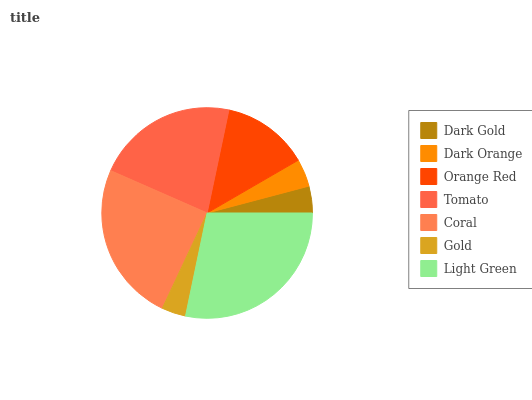Is Gold the minimum?
Answer yes or no. Yes. Is Light Green the maximum?
Answer yes or no. Yes. Is Dark Orange the minimum?
Answer yes or no. No. Is Dark Orange the maximum?
Answer yes or no. No. Is Dark Orange greater than Dark Gold?
Answer yes or no. Yes. Is Dark Gold less than Dark Orange?
Answer yes or no. Yes. Is Dark Gold greater than Dark Orange?
Answer yes or no. No. Is Dark Orange less than Dark Gold?
Answer yes or no. No. Is Orange Red the high median?
Answer yes or no. Yes. Is Orange Red the low median?
Answer yes or no. Yes. Is Light Green the high median?
Answer yes or no. No. Is Dark Orange the low median?
Answer yes or no. No. 